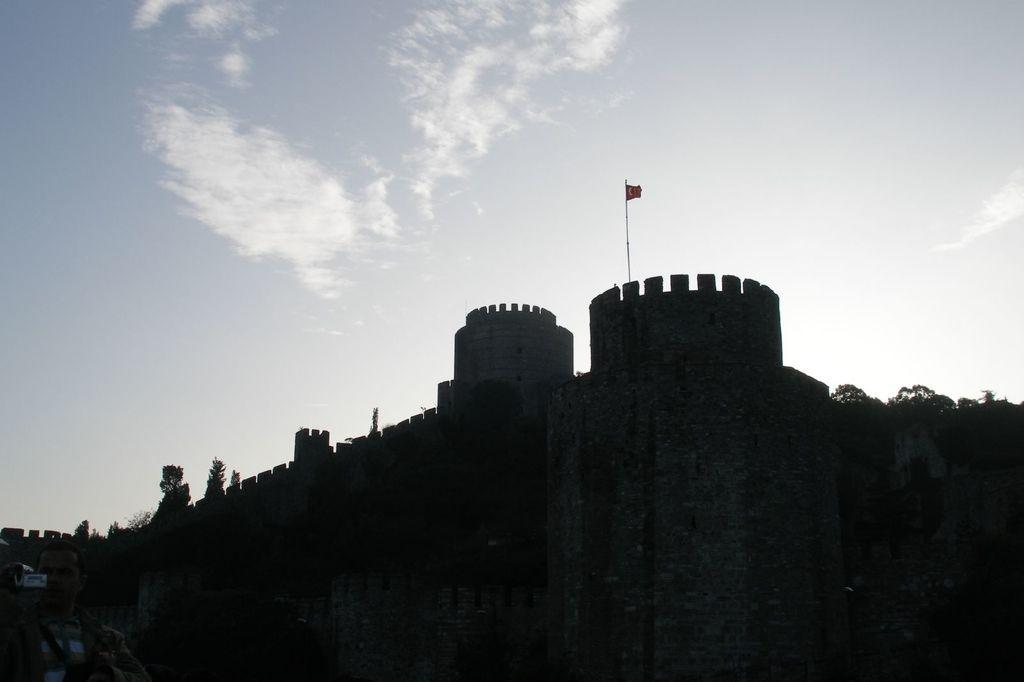What is the main structure in the image? There is a castle in the image. What is located above the castle? The castle has a flag above it. What can be seen in the sky in the image? The sky is visible in the image, and there are clouds in it. How many daughters are playing with the beef in the image? There are no daughters or beef present in the image. 